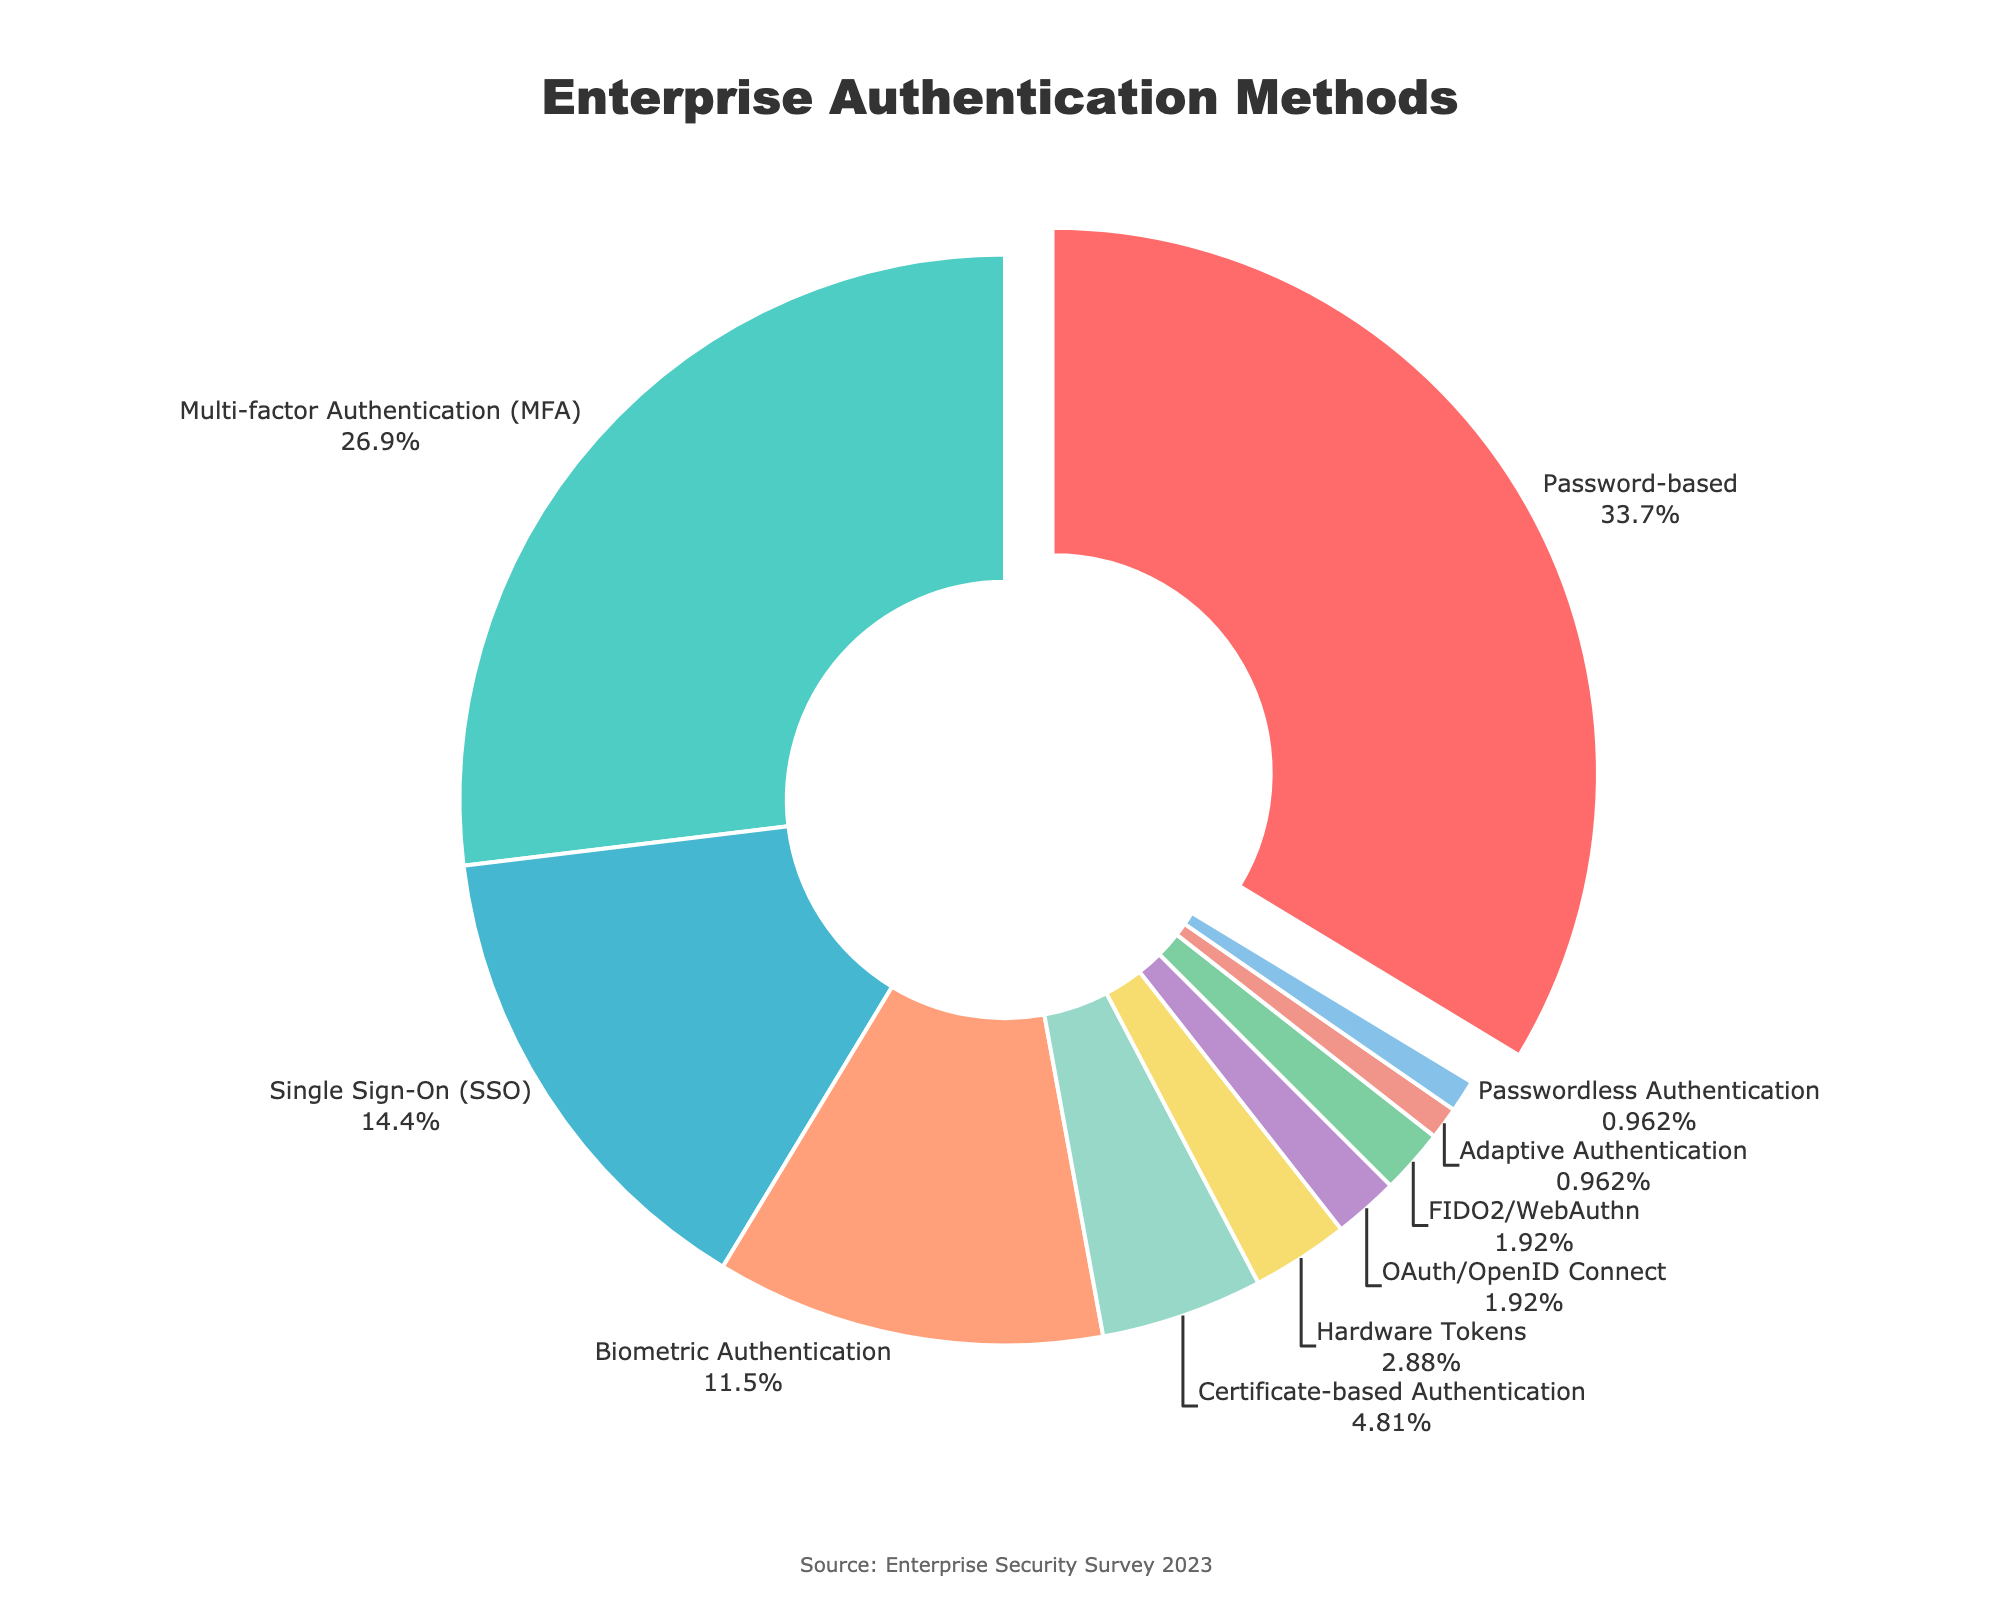Which authentication method has the highest usage percentage? The largest segment in the pie chart indicates the authentication method with the highest percentage. The label shows "Password-based" with 35%, which is the maximum value.
Answer: Password-based What is the combined usage percentage of Multi-factor Authentication (MFA) and Single Sign-On (SSO)? To find the combined percentage of MFA and SSO, add their individual percentages: 28% (MFA) + 15% (SSO) = 43%.
Answer: 43% How much more common is Password-based authentication compared to Biometric Authentication? Subtract the percentage of Biometric Authentication from the percentage of Password-based authentication: 35% - 12% = 23%.
Answer: 23% Which authentication methods have less than 5% usage? Examine the segments of the pie chart which have percentages less than 5%. These are Certificate-based Authentication (5%), Hardware Tokens (3%), OAuth/OpenID Connect (2%), FIDO2/WebAuthn (2%), Adaptive Authentication (1%), and Passwordless Authentication (1%).
Answer: Hardware Tokens, OAuth/OpenID Connect, FIDO2/WebAuthn, Adaptive Authentication, Passwordless Authentication What is the color associated with Multi-factor Authentication (MFA) in the pie chart? Observe the pie chart and identify the color segment labeled "Multi-factor Authentication (MFA)." It is colored green.
Answer: Green What is the percentage difference between the least and most used authentication methods? Identify the least used method (Adaptive Authentication at 1%) and the most used method (Password-based at 35%). The difference is 35% - 1% = 34%.
Answer: 34% How many authentication methods are used by less than 2% of users each? Identify and count the pie chart segments representing less than 2% usage: OAuth/OpenID Connect (2%), FIDO2/WebAuthn (2%), Adaptive Authentication (1%), Passwordless Authentication (1%).
Answer: 2 Is Single Sign-On (SSO) usage more than twice that of Biometric Authentication? Compare the percentage of SSO (15%) to twice the percentage of Biometric Authentication (12% * 2 = 24%). Since 15% is less than 24%, the usage is not more than twice.
Answer: No By how many percentage points does Multi-factor Authentication (MFA) exceed Certificate-based Authentication? Subtract the percentage of Certificate-based Authentication from the percentage of Multi-factor Authentication: 28% - 5% = 23%.
Answer: 23% Which authentication method has the smallest segment in the pie chart, and what is its percentage? Identify the smallest segment in the pie chart, labeled "Passwordless Authentication," with a percentage of 1%.
Answer: Passwordless Authentication, 1% 